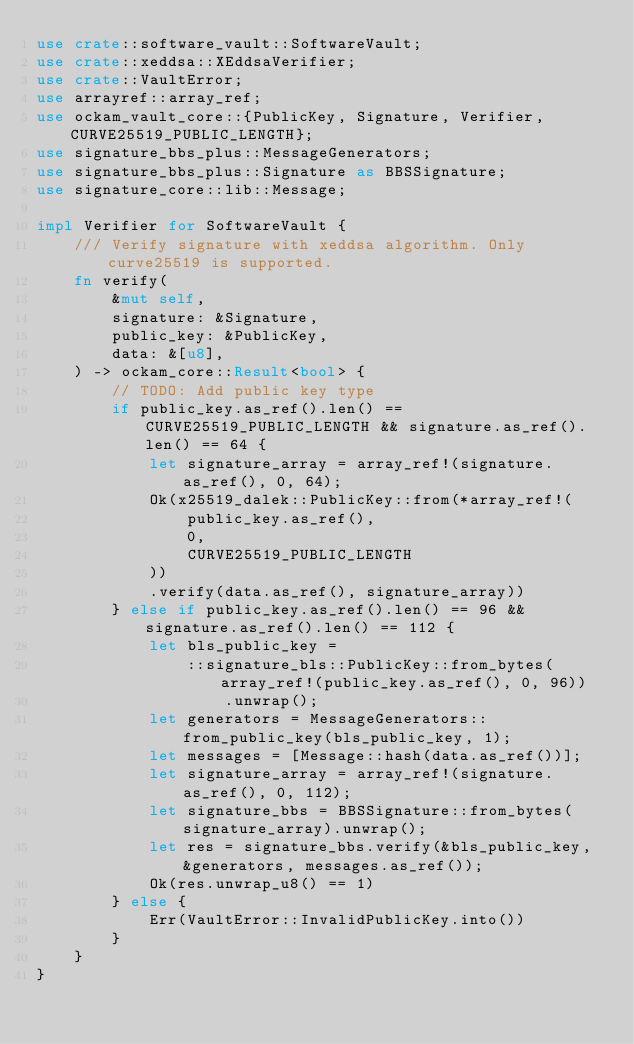Convert code to text. <code><loc_0><loc_0><loc_500><loc_500><_Rust_>use crate::software_vault::SoftwareVault;
use crate::xeddsa::XEddsaVerifier;
use crate::VaultError;
use arrayref::array_ref;
use ockam_vault_core::{PublicKey, Signature, Verifier, CURVE25519_PUBLIC_LENGTH};
use signature_bbs_plus::MessageGenerators;
use signature_bbs_plus::Signature as BBSSignature;
use signature_core::lib::Message;

impl Verifier for SoftwareVault {
    /// Verify signature with xeddsa algorithm. Only curve25519 is supported.
    fn verify(
        &mut self,
        signature: &Signature,
        public_key: &PublicKey,
        data: &[u8],
    ) -> ockam_core::Result<bool> {
        // TODO: Add public key type
        if public_key.as_ref().len() == CURVE25519_PUBLIC_LENGTH && signature.as_ref().len() == 64 {
            let signature_array = array_ref!(signature.as_ref(), 0, 64);
            Ok(x25519_dalek::PublicKey::from(*array_ref!(
                public_key.as_ref(),
                0,
                CURVE25519_PUBLIC_LENGTH
            ))
            .verify(data.as_ref(), signature_array))
        } else if public_key.as_ref().len() == 96 && signature.as_ref().len() == 112 {
            let bls_public_key =
                ::signature_bls::PublicKey::from_bytes(array_ref!(public_key.as_ref(), 0, 96))
                    .unwrap();
            let generators = MessageGenerators::from_public_key(bls_public_key, 1);
            let messages = [Message::hash(data.as_ref())];
            let signature_array = array_ref!(signature.as_ref(), 0, 112);
            let signature_bbs = BBSSignature::from_bytes(signature_array).unwrap();
            let res = signature_bbs.verify(&bls_public_key, &generators, messages.as_ref());
            Ok(res.unwrap_u8() == 1)
        } else {
            Err(VaultError::InvalidPublicKey.into())
        }
    }
}
</code> 